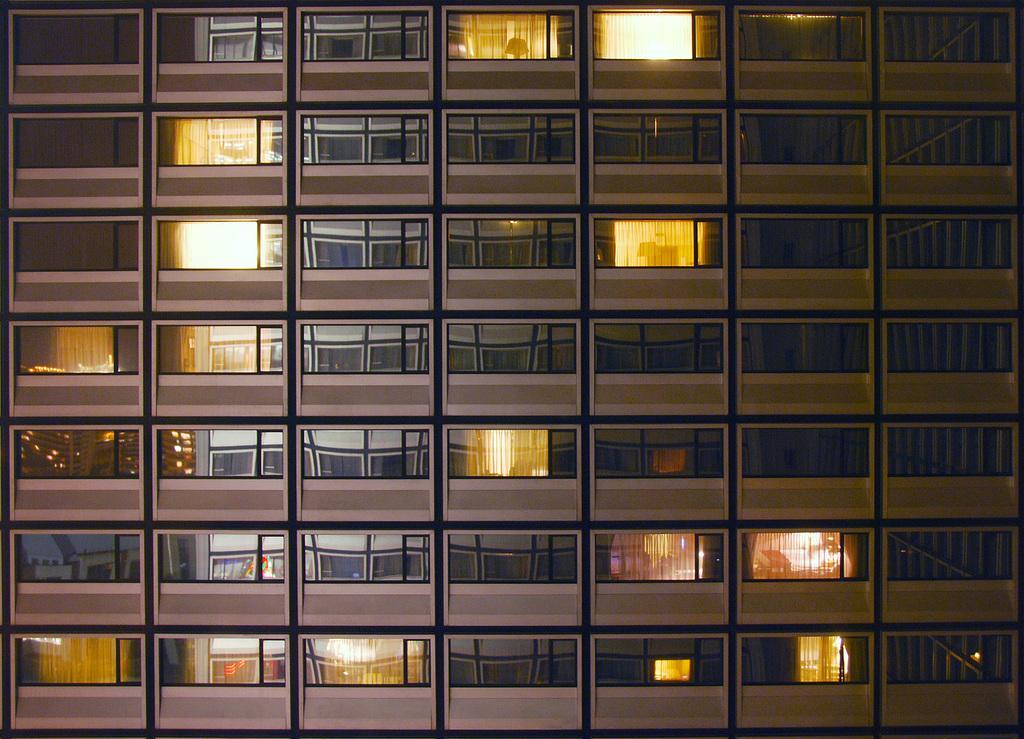Describe this image in one or two sentences. There is a building, it has a lot of rooms and some of the rooms were lightened up. 